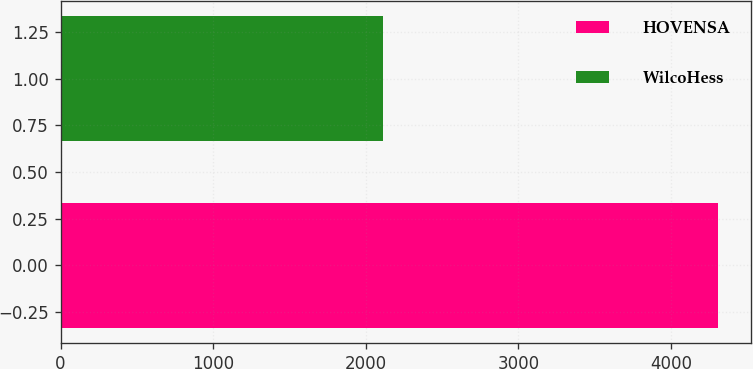Convert chart to OTSL. <chart><loc_0><loc_0><loc_500><loc_500><bar_chart><fcel>HOVENSA<fcel>WilcoHess<nl><fcel>4307<fcel>2113<nl></chart> 